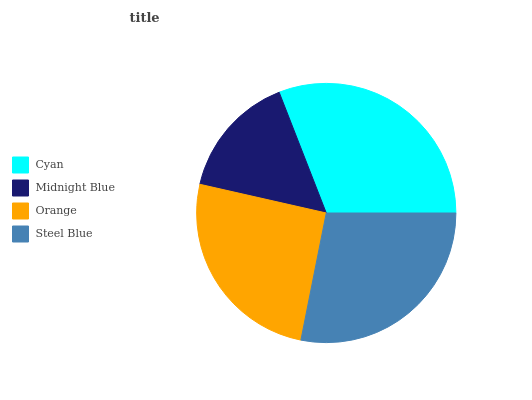Is Midnight Blue the minimum?
Answer yes or no. Yes. Is Cyan the maximum?
Answer yes or no. Yes. Is Orange the minimum?
Answer yes or no. No. Is Orange the maximum?
Answer yes or no. No. Is Orange greater than Midnight Blue?
Answer yes or no. Yes. Is Midnight Blue less than Orange?
Answer yes or no. Yes. Is Midnight Blue greater than Orange?
Answer yes or no. No. Is Orange less than Midnight Blue?
Answer yes or no. No. Is Steel Blue the high median?
Answer yes or no. Yes. Is Orange the low median?
Answer yes or no. Yes. Is Cyan the high median?
Answer yes or no. No. Is Cyan the low median?
Answer yes or no. No. 